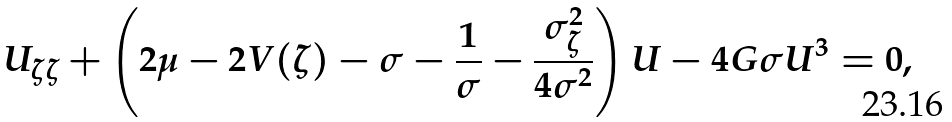<formula> <loc_0><loc_0><loc_500><loc_500>U _ { \zeta \zeta } + \left ( 2 \mu - 2 V ( \zeta ) - \sigma - \frac { 1 } { \sigma } - \frac { \sigma _ { \zeta } ^ { 2 } } { 4 \sigma ^ { 2 } } \right ) U - 4 G \sigma { U ^ { 3 } } = 0 ,</formula> 